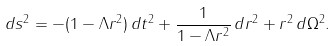<formula> <loc_0><loc_0><loc_500><loc_500>d s ^ { 2 } = - ( 1 - \Lambda r ^ { 2 } ) \, d t ^ { 2 } + { \frac { 1 } { 1 - \Lambda r ^ { 2 } } } \, d r ^ { 2 } + r ^ { 2 } \, d \Omega ^ { 2 } .</formula> 